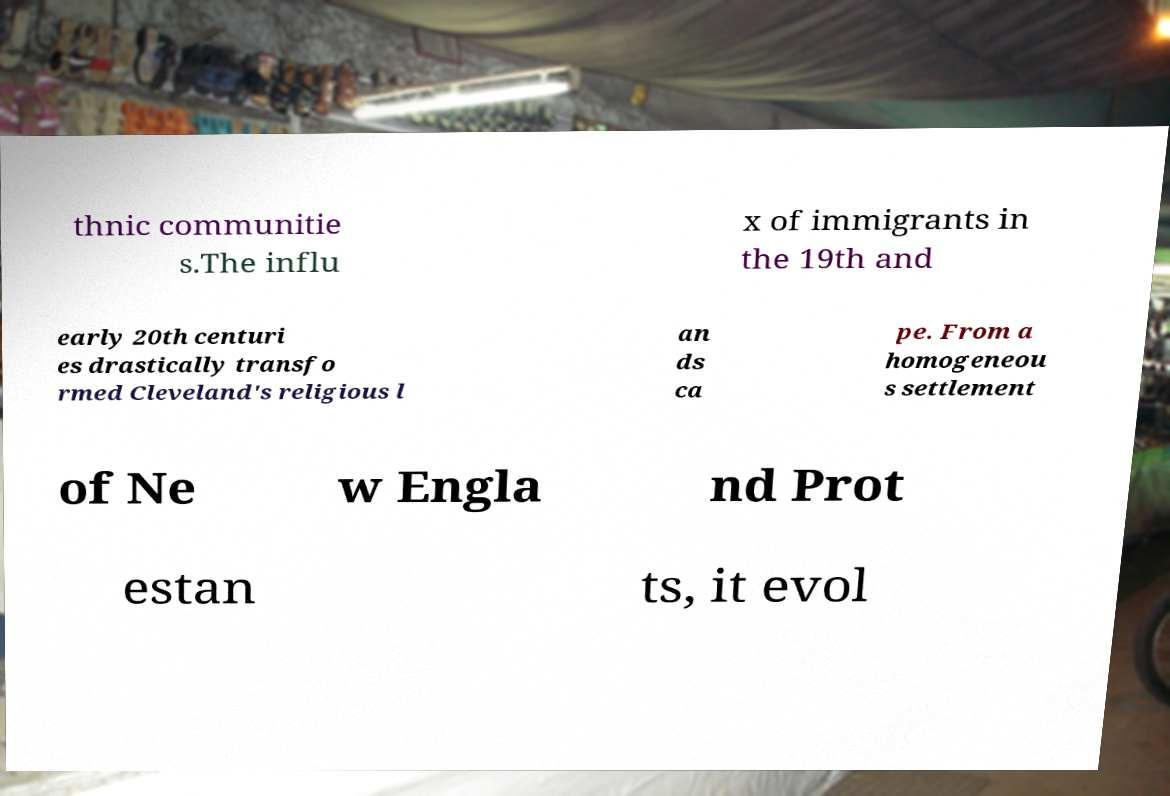There's text embedded in this image that I need extracted. Can you transcribe it verbatim? thnic communitie s.The influ x of immigrants in the 19th and early 20th centuri es drastically transfo rmed Cleveland's religious l an ds ca pe. From a homogeneou s settlement of Ne w Engla nd Prot estan ts, it evol 